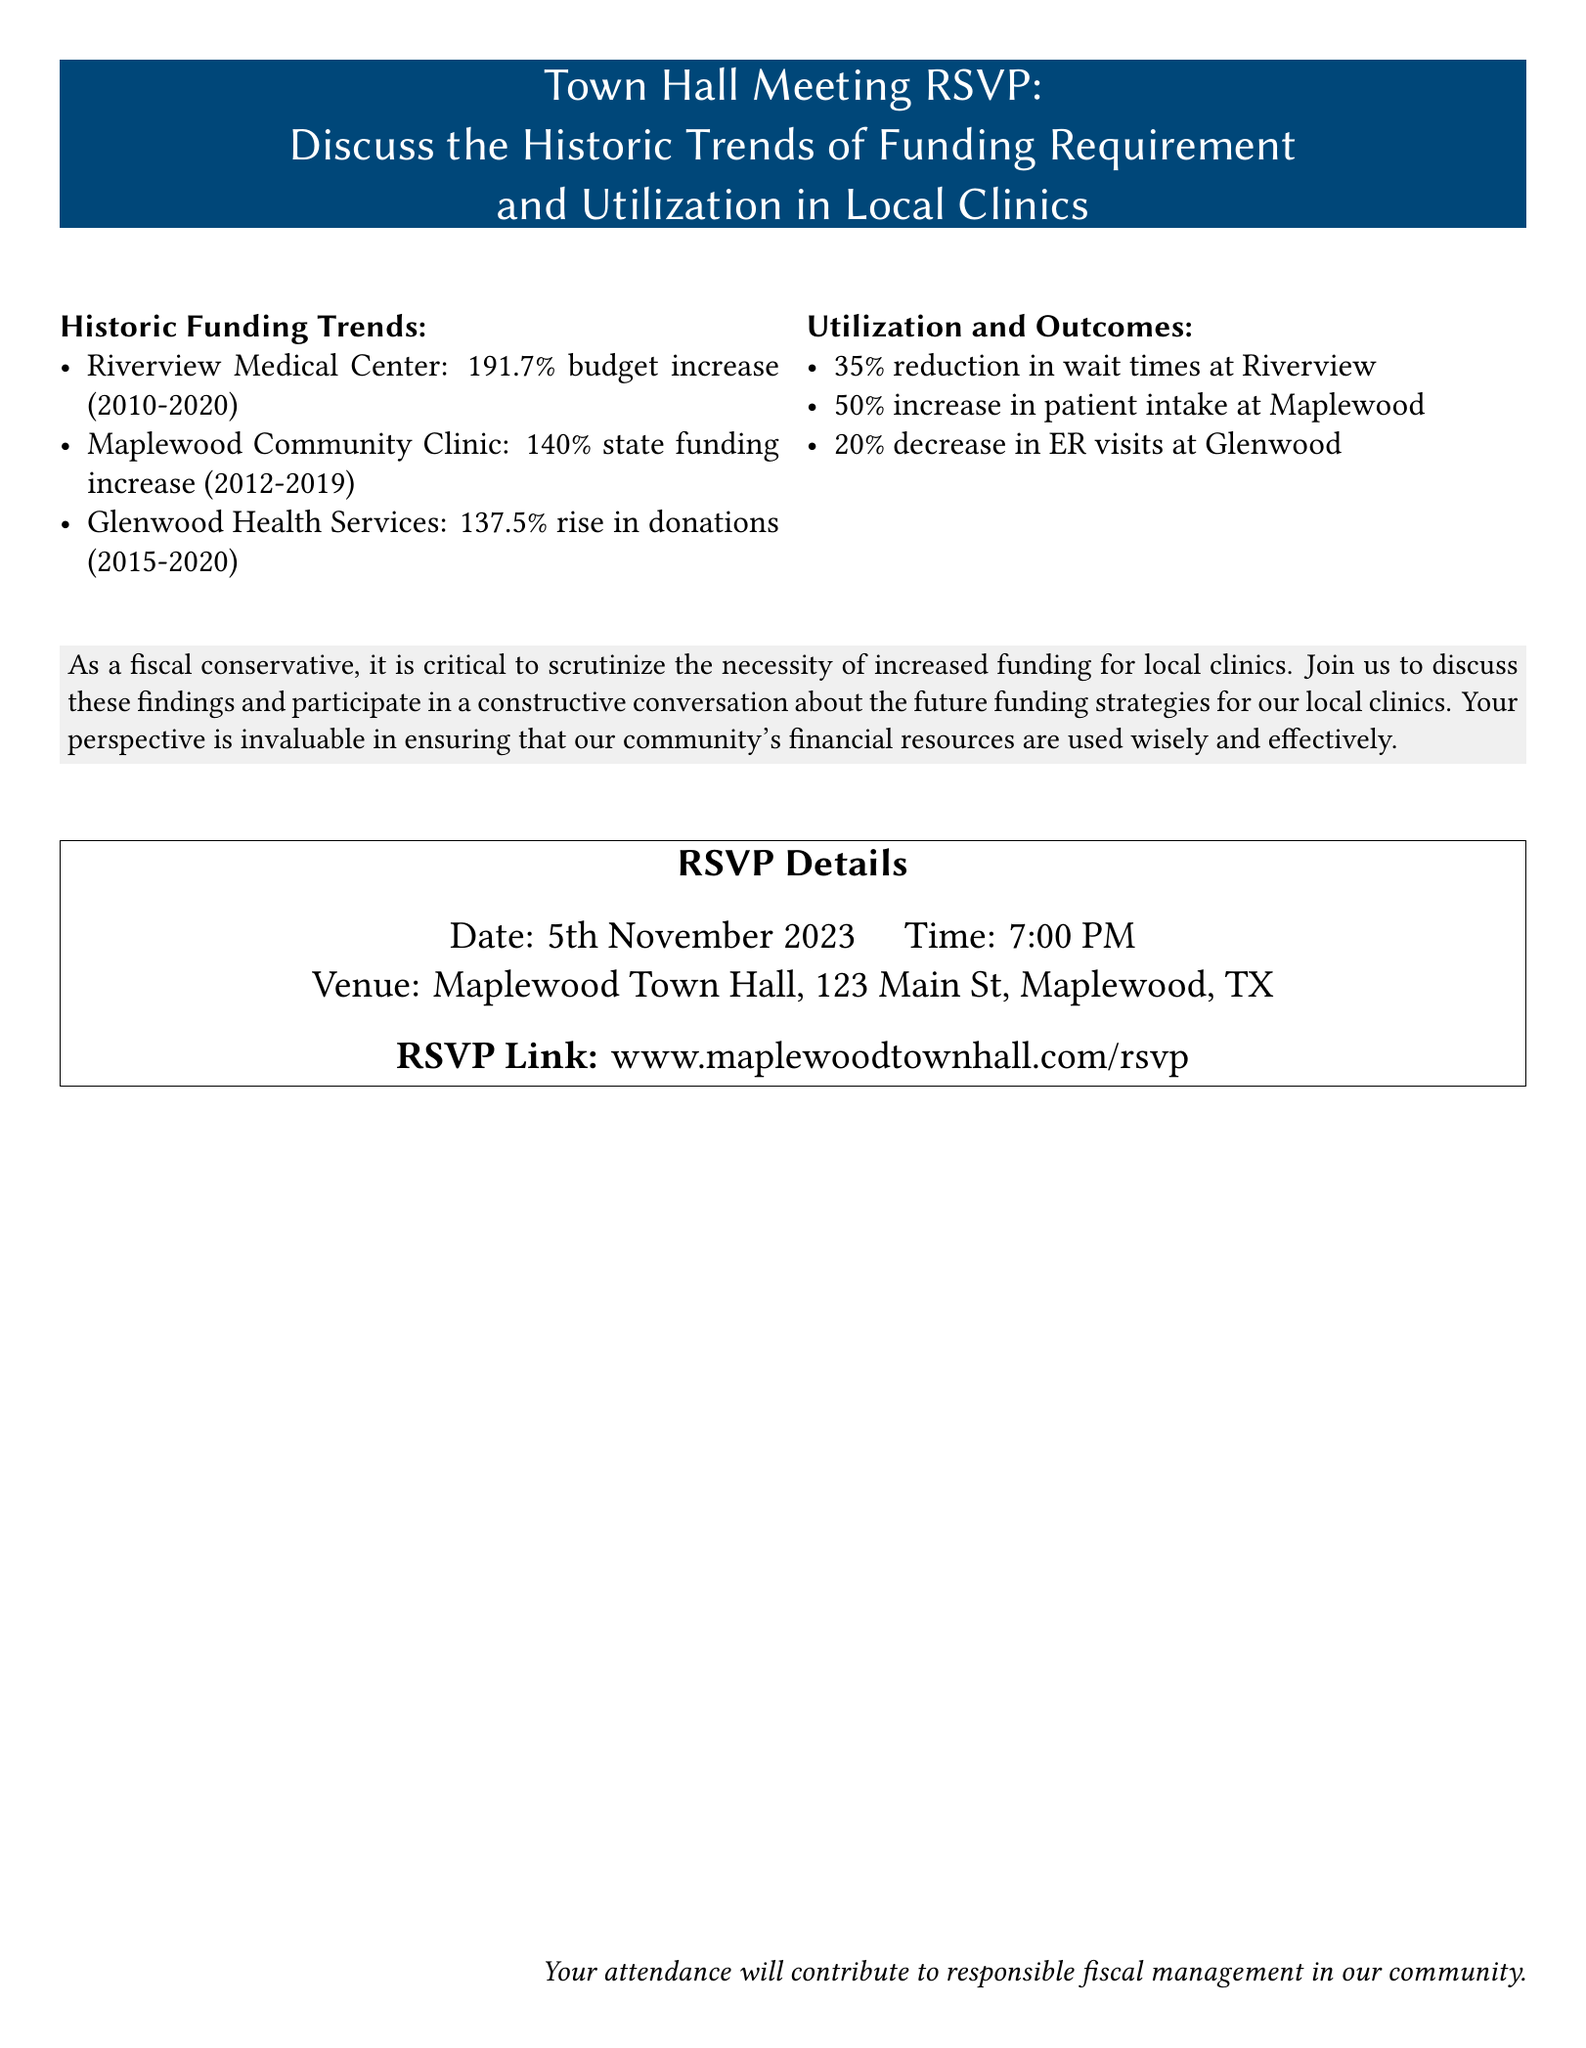What is the percentage increase in budget for Riverview Medical Center from 2010 to 2020? The document states that Riverview Medical Center experienced a budget increase of 191.7% from 2010 to 2020.
Answer: 191.7% What is the funding increase for Maplewood Community Clinic from 2012 to 2019? According to the document, Maplewood Community Clinic had a state funding increase of 140% during the years 2012 to 2019.
Answer: 140% Which clinic saw a 20% decrease in ER visits? The document mentions that Glenwood Health Services experienced a 20% decrease in emergency room visits.
Answer: Glenwood Health Services What was the wait time reduction at Riverview Medical Center? The document indicates that there was a 35% reduction in wait times at Riverview Medical Center.
Answer: 35% What is the date of the Town Hall Meeting? The RSVP card specifies that the date of the Town Hall Meeting is 5th November 2023.
Answer: 5th November 2023 How many patients did Maplewood see an increase in intake? The document states that there was a 50% increase in patient intake at Maplewood Community Clinic.
Answer: 50% Where is the Town Hall Meeting being held? The document lists Maplewood Town Hall at 123 Main St, Maplewood, TX as the venue for the meeting.
Answer: Maplewood Town Hall, 123 Main St, Maplewood, TX What is the primary purpose of the Town Hall Meeting? The invitation indicates that the meeting is intended to discuss the historic trends of funding and utilization in local clinics.
Answer: Discuss funding trends and utilization What is the RSVP link for the meeting? The document provides a specific web address for RSVPs, which is www.maplewoodtownhall.com/rsvp.
Answer: www.maplewoodtownhall.com/rsvp 